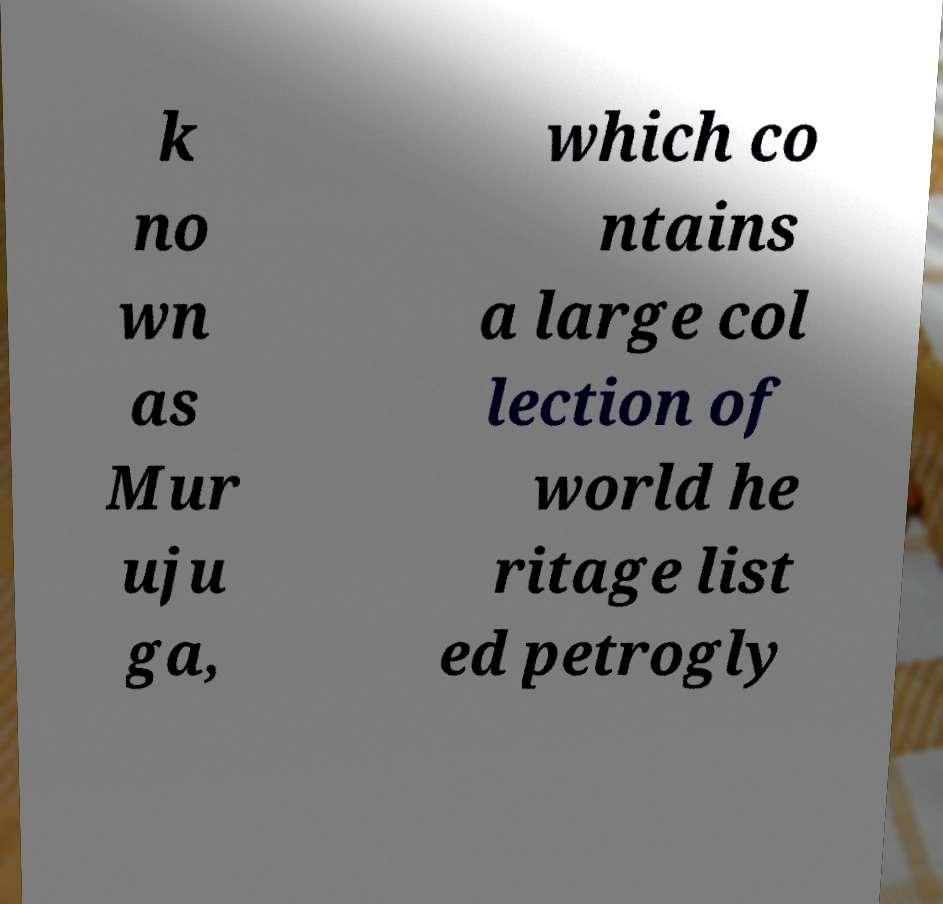Please read and relay the text visible in this image. What does it say? k no wn as Mur uju ga, which co ntains a large col lection of world he ritage list ed petrogly 